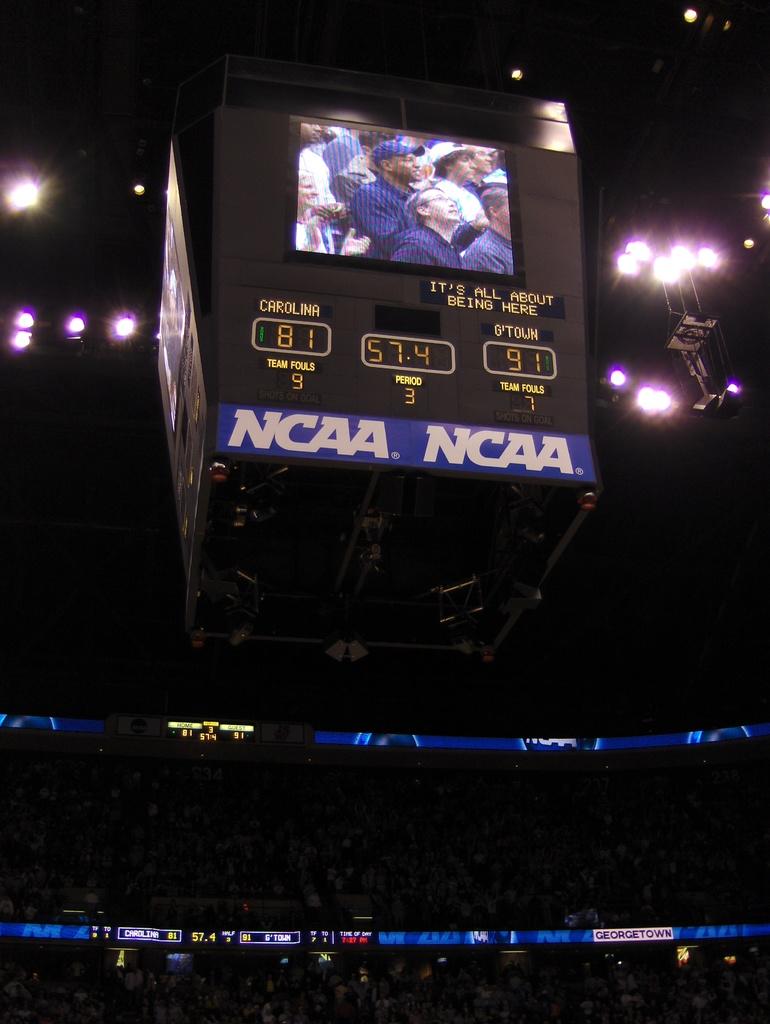What is the sport being played?
Give a very brief answer. Basketball. What is the score?
Offer a very short reply. 81-91. 